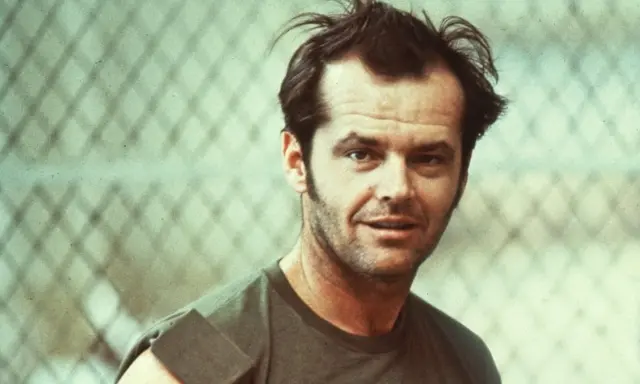What do you think this person's thoughts might be in this moment? The person's serious and introspective expression suggests that he might be lost in deep thought, perhaps contemplating something significant. It's possible that he is reflecting on a personal matter or a decision he needs to make. The relaxed, casual setting indicates that he is comfortable but mentally engaged with his thoughts. Do you think this setting is important to the overall vibe of the image? Yes, the setting plays an integral role in establishing the atmosphere of the image. The chain-link fence adds a rugged, urban feel, contrasting with the subject's casual attire and contemplative pose. This juxtaposition enhances the depth and narrative potential of the photograph, suggesting themes of resilience, personal reflection, and possibly a desire for freedom or breaking boundaries. 